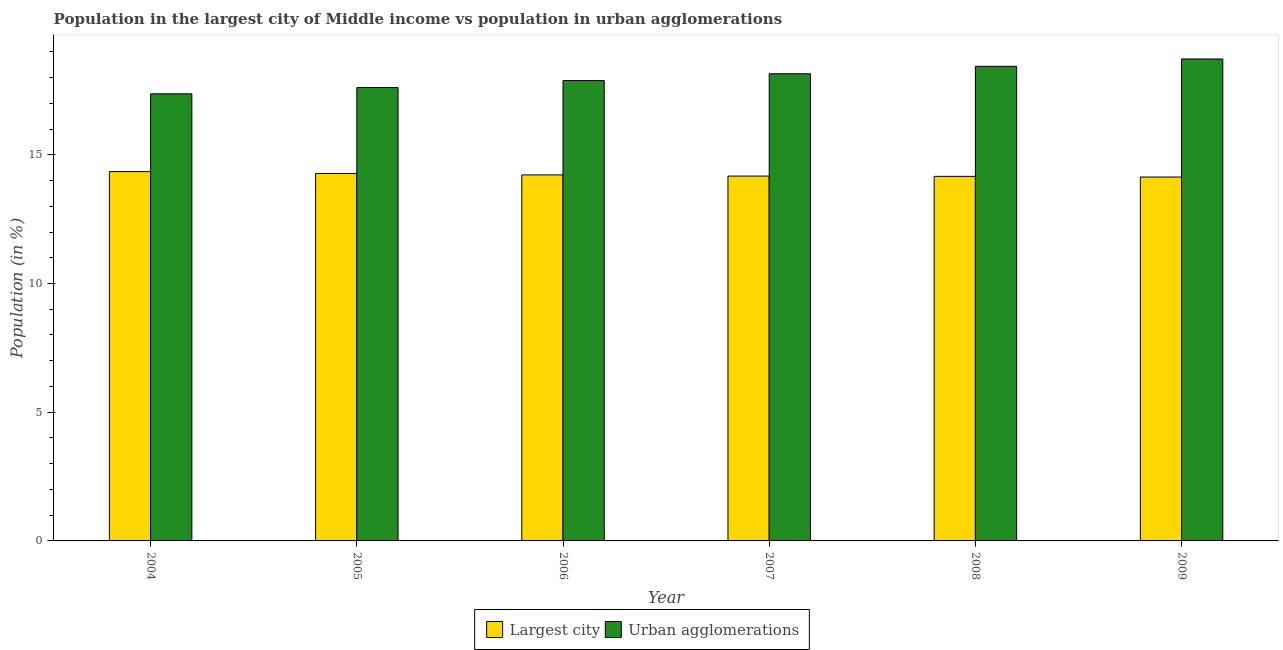How many groups of bars are there?
Your response must be concise. 6. Are the number of bars per tick equal to the number of legend labels?
Offer a terse response. Yes. Are the number of bars on each tick of the X-axis equal?
Provide a succinct answer. Yes. How many bars are there on the 5th tick from the left?
Ensure brevity in your answer.  2. What is the population in the largest city in 2004?
Your response must be concise. 14.35. Across all years, what is the maximum population in urban agglomerations?
Your response must be concise. 18.72. Across all years, what is the minimum population in the largest city?
Offer a terse response. 14.14. In which year was the population in the largest city maximum?
Offer a very short reply. 2004. What is the total population in urban agglomerations in the graph?
Provide a succinct answer. 108.17. What is the difference between the population in urban agglomerations in 2006 and that in 2009?
Your response must be concise. -0.84. What is the difference between the population in urban agglomerations in 2005 and the population in the largest city in 2004?
Ensure brevity in your answer.  0.24. What is the average population in urban agglomerations per year?
Make the answer very short. 18.03. What is the ratio of the population in the largest city in 2006 to that in 2008?
Your answer should be very brief. 1. What is the difference between the highest and the second highest population in the largest city?
Your response must be concise. 0.07. What is the difference between the highest and the lowest population in the largest city?
Provide a short and direct response. 0.21. In how many years, is the population in urban agglomerations greater than the average population in urban agglomerations taken over all years?
Offer a terse response. 3. Is the sum of the population in the largest city in 2004 and 2007 greater than the maximum population in urban agglomerations across all years?
Offer a very short reply. Yes. What does the 2nd bar from the left in 2008 represents?
Your answer should be compact. Urban agglomerations. What does the 2nd bar from the right in 2006 represents?
Make the answer very short. Largest city. Are all the bars in the graph horizontal?
Keep it short and to the point. No. Where does the legend appear in the graph?
Provide a short and direct response. Bottom center. How many legend labels are there?
Offer a terse response. 2. What is the title of the graph?
Offer a very short reply. Population in the largest city of Middle income vs population in urban agglomerations. What is the label or title of the X-axis?
Make the answer very short. Year. What is the label or title of the Y-axis?
Offer a terse response. Population (in %). What is the Population (in %) in Largest city in 2004?
Make the answer very short. 14.35. What is the Population (in %) in Urban agglomerations in 2004?
Your answer should be very brief. 17.37. What is the Population (in %) in Largest city in 2005?
Offer a very short reply. 14.27. What is the Population (in %) of Urban agglomerations in 2005?
Your answer should be very brief. 17.61. What is the Population (in %) of Largest city in 2006?
Ensure brevity in your answer.  14.22. What is the Population (in %) of Urban agglomerations in 2006?
Provide a short and direct response. 17.88. What is the Population (in %) in Largest city in 2007?
Your response must be concise. 14.17. What is the Population (in %) in Urban agglomerations in 2007?
Provide a succinct answer. 18.15. What is the Population (in %) of Largest city in 2008?
Your answer should be very brief. 14.16. What is the Population (in %) of Urban agglomerations in 2008?
Your response must be concise. 18.44. What is the Population (in %) of Largest city in 2009?
Offer a terse response. 14.14. What is the Population (in %) of Urban agglomerations in 2009?
Your answer should be very brief. 18.72. Across all years, what is the maximum Population (in %) in Largest city?
Your answer should be very brief. 14.35. Across all years, what is the maximum Population (in %) in Urban agglomerations?
Offer a terse response. 18.72. Across all years, what is the minimum Population (in %) in Largest city?
Keep it short and to the point. 14.14. Across all years, what is the minimum Population (in %) of Urban agglomerations?
Offer a terse response. 17.37. What is the total Population (in %) of Largest city in the graph?
Your answer should be very brief. 85.31. What is the total Population (in %) of Urban agglomerations in the graph?
Make the answer very short. 108.17. What is the difference between the Population (in %) in Largest city in 2004 and that in 2005?
Ensure brevity in your answer.  0.07. What is the difference between the Population (in %) of Urban agglomerations in 2004 and that in 2005?
Ensure brevity in your answer.  -0.24. What is the difference between the Population (in %) of Largest city in 2004 and that in 2006?
Provide a succinct answer. 0.13. What is the difference between the Population (in %) of Urban agglomerations in 2004 and that in 2006?
Offer a very short reply. -0.51. What is the difference between the Population (in %) of Largest city in 2004 and that in 2007?
Your answer should be compact. 0.17. What is the difference between the Population (in %) of Urban agglomerations in 2004 and that in 2007?
Provide a succinct answer. -0.78. What is the difference between the Population (in %) in Largest city in 2004 and that in 2008?
Give a very brief answer. 0.18. What is the difference between the Population (in %) of Urban agglomerations in 2004 and that in 2008?
Ensure brevity in your answer.  -1.07. What is the difference between the Population (in %) in Largest city in 2004 and that in 2009?
Make the answer very short. 0.21. What is the difference between the Population (in %) of Urban agglomerations in 2004 and that in 2009?
Keep it short and to the point. -1.35. What is the difference between the Population (in %) in Largest city in 2005 and that in 2006?
Provide a succinct answer. 0.06. What is the difference between the Population (in %) of Urban agglomerations in 2005 and that in 2006?
Ensure brevity in your answer.  -0.27. What is the difference between the Population (in %) of Largest city in 2005 and that in 2007?
Your answer should be very brief. 0.1. What is the difference between the Population (in %) of Urban agglomerations in 2005 and that in 2007?
Ensure brevity in your answer.  -0.54. What is the difference between the Population (in %) of Largest city in 2005 and that in 2008?
Offer a very short reply. 0.11. What is the difference between the Population (in %) in Urban agglomerations in 2005 and that in 2008?
Offer a very short reply. -0.82. What is the difference between the Population (in %) of Largest city in 2005 and that in 2009?
Provide a succinct answer. 0.14. What is the difference between the Population (in %) in Urban agglomerations in 2005 and that in 2009?
Offer a very short reply. -1.11. What is the difference between the Population (in %) of Largest city in 2006 and that in 2007?
Your response must be concise. 0.05. What is the difference between the Population (in %) of Urban agglomerations in 2006 and that in 2007?
Offer a terse response. -0.27. What is the difference between the Population (in %) of Largest city in 2006 and that in 2008?
Your answer should be very brief. 0.06. What is the difference between the Population (in %) in Urban agglomerations in 2006 and that in 2008?
Ensure brevity in your answer.  -0.55. What is the difference between the Population (in %) in Largest city in 2006 and that in 2009?
Provide a short and direct response. 0.08. What is the difference between the Population (in %) of Urban agglomerations in 2006 and that in 2009?
Your answer should be very brief. -0.84. What is the difference between the Population (in %) in Largest city in 2007 and that in 2008?
Your answer should be very brief. 0.01. What is the difference between the Population (in %) of Urban agglomerations in 2007 and that in 2008?
Your answer should be compact. -0.29. What is the difference between the Population (in %) in Largest city in 2007 and that in 2009?
Ensure brevity in your answer.  0.04. What is the difference between the Population (in %) in Urban agglomerations in 2007 and that in 2009?
Your answer should be very brief. -0.57. What is the difference between the Population (in %) in Largest city in 2008 and that in 2009?
Make the answer very short. 0.03. What is the difference between the Population (in %) in Urban agglomerations in 2008 and that in 2009?
Ensure brevity in your answer.  -0.29. What is the difference between the Population (in %) in Largest city in 2004 and the Population (in %) in Urban agglomerations in 2005?
Provide a succinct answer. -3.27. What is the difference between the Population (in %) of Largest city in 2004 and the Population (in %) of Urban agglomerations in 2006?
Provide a succinct answer. -3.54. What is the difference between the Population (in %) of Largest city in 2004 and the Population (in %) of Urban agglomerations in 2007?
Ensure brevity in your answer.  -3.8. What is the difference between the Population (in %) in Largest city in 2004 and the Population (in %) in Urban agglomerations in 2008?
Give a very brief answer. -4.09. What is the difference between the Population (in %) of Largest city in 2004 and the Population (in %) of Urban agglomerations in 2009?
Ensure brevity in your answer.  -4.38. What is the difference between the Population (in %) in Largest city in 2005 and the Population (in %) in Urban agglomerations in 2006?
Keep it short and to the point. -3.61. What is the difference between the Population (in %) in Largest city in 2005 and the Population (in %) in Urban agglomerations in 2007?
Your answer should be compact. -3.87. What is the difference between the Population (in %) of Largest city in 2005 and the Population (in %) of Urban agglomerations in 2008?
Your response must be concise. -4.16. What is the difference between the Population (in %) of Largest city in 2005 and the Population (in %) of Urban agglomerations in 2009?
Keep it short and to the point. -4.45. What is the difference between the Population (in %) in Largest city in 2006 and the Population (in %) in Urban agglomerations in 2007?
Keep it short and to the point. -3.93. What is the difference between the Population (in %) in Largest city in 2006 and the Population (in %) in Urban agglomerations in 2008?
Provide a short and direct response. -4.22. What is the difference between the Population (in %) of Largest city in 2006 and the Population (in %) of Urban agglomerations in 2009?
Your answer should be compact. -4.5. What is the difference between the Population (in %) of Largest city in 2007 and the Population (in %) of Urban agglomerations in 2008?
Offer a very short reply. -4.26. What is the difference between the Population (in %) in Largest city in 2007 and the Population (in %) in Urban agglomerations in 2009?
Your response must be concise. -4.55. What is the difference between the Population (in %) in Largest city in 2008 and the Population (in %) in Urban agglomerations in 2009?
Provide a succinct answer. -4.56. What is the average Population (in %) in Largest city per year?
Offer a terse response. 14.22. What is the average Population (in %) of Urban agglomerations per year?
Ensure brevity in your answer.  18.03. In the year 2004, what is the difference between the Population (in %) in Largest city and Population (in %) in Urban agglomerations?
Provide a succinct answer. -3.02. In the year 2005, what is the difference between the Population (in %) in Largest city and Population (in %) in Urban agglomerations?
Give a very brief answer. -3.34. In the year 2006, what is the difference between the Population (in %) of Largest city and Population (in %) of Urban agglomerations?
Ensure brevity in your answer.  -3.66. In the year 2007, what is the difference between the Population (in %) of Largest city and Population (in %) of Urban agglomerations?
Provide a succinct answer. -3.97. In the year 2008, what is the difference between the Population (in %) in Largest city and Population (in %) in Urban agglomerations?
Offer a very short reply. -4.27. In the year 2009, what is the difference between the Population (in %) in Largest city and Population (in %) in Urban agglomerations?
Offer a very short reply. -4.59. What is the ratio of the Population (in %) of Largest city in 2004 to that in 2005?
Make the answer very short. 1. What is the ratio of the Population (in %) of Urban agglomerations in 2004 to that in 2005?
Your answer should be compact. 0.99. What is the ratio of the Population (in %) of Urban agglomerations in 2004 to that in 2006?
Offer a terse response. 0.97. What is the ratio of the Population (in %) in Largest city in 2004 to that in 2007?
Your answer should be very brief. 1.01. What is the ratio of the Population (in %) of Urban agglomerations in 2004 to that in 2007?
Ensure brevity in your answer.  0.96. What is the ratio of the Population (in %) in Urban agglomerations in 2004 to that in 2008?
Your response must be concise. 0.94. What is the ratio of the Population (in %) of Largest city in 2004 to that in 2009?
Offer a very short reply. 1.01. What is the ratio of the Population (in %) in Urban agglomerations in 2004 to that in 2009?
Your answer should be compact. 0.93. What is the ratio of the Population (in %) of Urban agglomerations in 2005 to that in 2006?
Offer a terse response. 0.98. What is the ratio of the Population (in %) of Largest city in 2005 to that in 2007?
Your answer should be compact. 1.01. What is the ratio of the Population (in %) in Urban agglomerations in 2005 to that in 2007?
Offer a terse response. 0.97. What is the ratio of the Population (in %) of Urban agglomerations in 2005 to that in 2008?
Offer a terse response. 0.96. What is the ratio of the Population (in %) of Largest city in 2005 to that in 2009?
Make the answer very short. 1.01. What is the ratio of the Population (in %) in Urban agglomerations in 2005 to that in 2009?
Provide a short and direct response. 0.94. What is the ratio of the Population (in %) in Largest city in 2006 to that in 2007?
Ensure brevity in your answer.  1. What is the ratio of the Population (in %) of Urban agglomerations in 2006 to that in 2007?
Provide a short and direct response. 0.99. What is the ratio of the Population (in %) of Urban agglomerations in 2006 to that in 2008?
Make the answer very short. 0.97. What is the ratio of the Population (in %) in Largest city in 2006 to that in 2009?
Offer a terse response. 1.01. What is the ratio of the Population (in %) in Urban agglomerations in 2006 to that in 2009?
Offer a very short reply. 0.96. What is the ratio of the Population (in %) in Largest city in 2007 to that in 2008?
Your answer should be very brief. 1. What is the ratio of the Population (in %) of Urban agglomerations in 2007 to that in 2008?
Your response must be concise. 0.98. What is the ratio of the Population (in %) of Urban agglomerations in 2007 to that in 2009?
Keep it short and to the point. 0.97. What is the ratio of the Population (in %) in Largest city in 2008 to that in 2009?
Your response must be concise. 1. What is the ratio of the Population (in %) of Urban agglomerations in 2008 to that in 2009?
Provide a succinct answer. 0.98. What is the difference between the highest and the second highest Population (in %) in Largest city?
Your answer should be very brief. 0.07. What is the difference between the highest and the second highest Population (in %) in Urban agglomerations?
Keep it short and to the point. 0.29. What is the difference between the highest and the lowest Population (in %) in Largest city?
Your response must be concise. 0.21. What is the difference between the highest and the lowest Population (in %) in Urban agglomerations?
Provide a short and direct response. 1.35. 